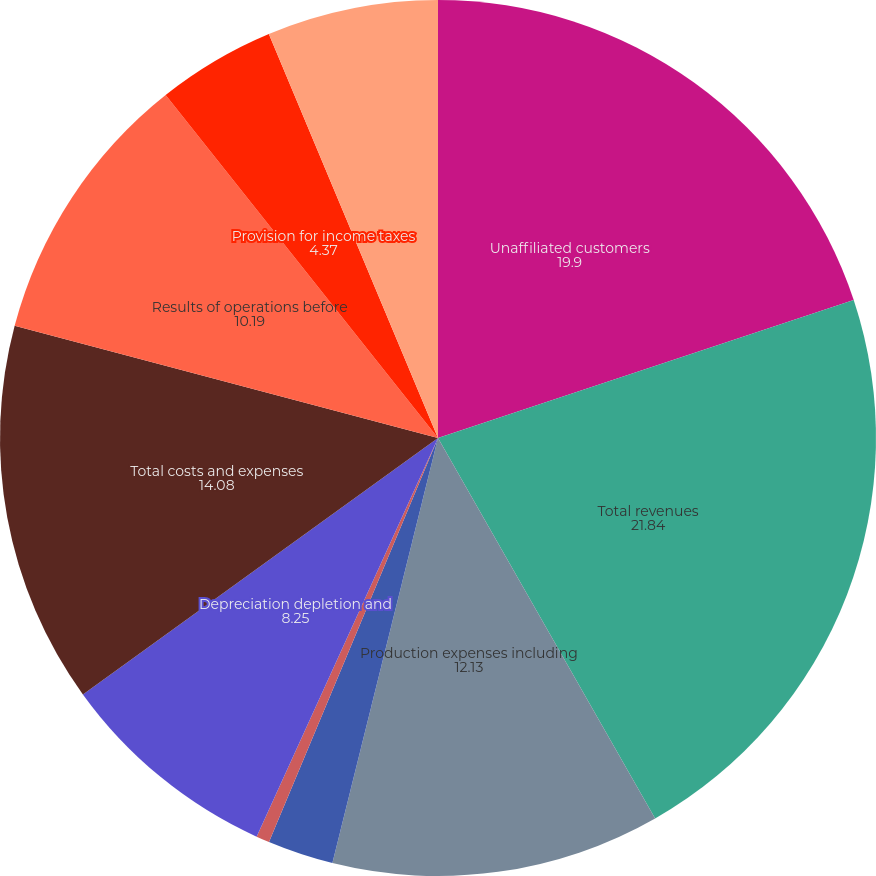Convert chart. <chart><loc_0><loc_0><loc_500><loc_500><pie_chart><fcel>Unaffiliated customers<fcel>Total revenues<fcel>Production expenses including<fcel>Exploration expenses including<fcel>General administrative and<fcel>Depreciation depletion and<fcel>Total costs and expenses<fcel>Results of operations before<fcel>Provision for income taxes<fcel>Results of operations<nl><fcel>19.9%<fcel>21.84%<fcel>12.13%<fcel>2.43%<fcel>0.49%<fcel>8.25%<fcel>14.08%<fcel>10.19%<fcel>4.37%<fcel>6.31%<nl></chart> 